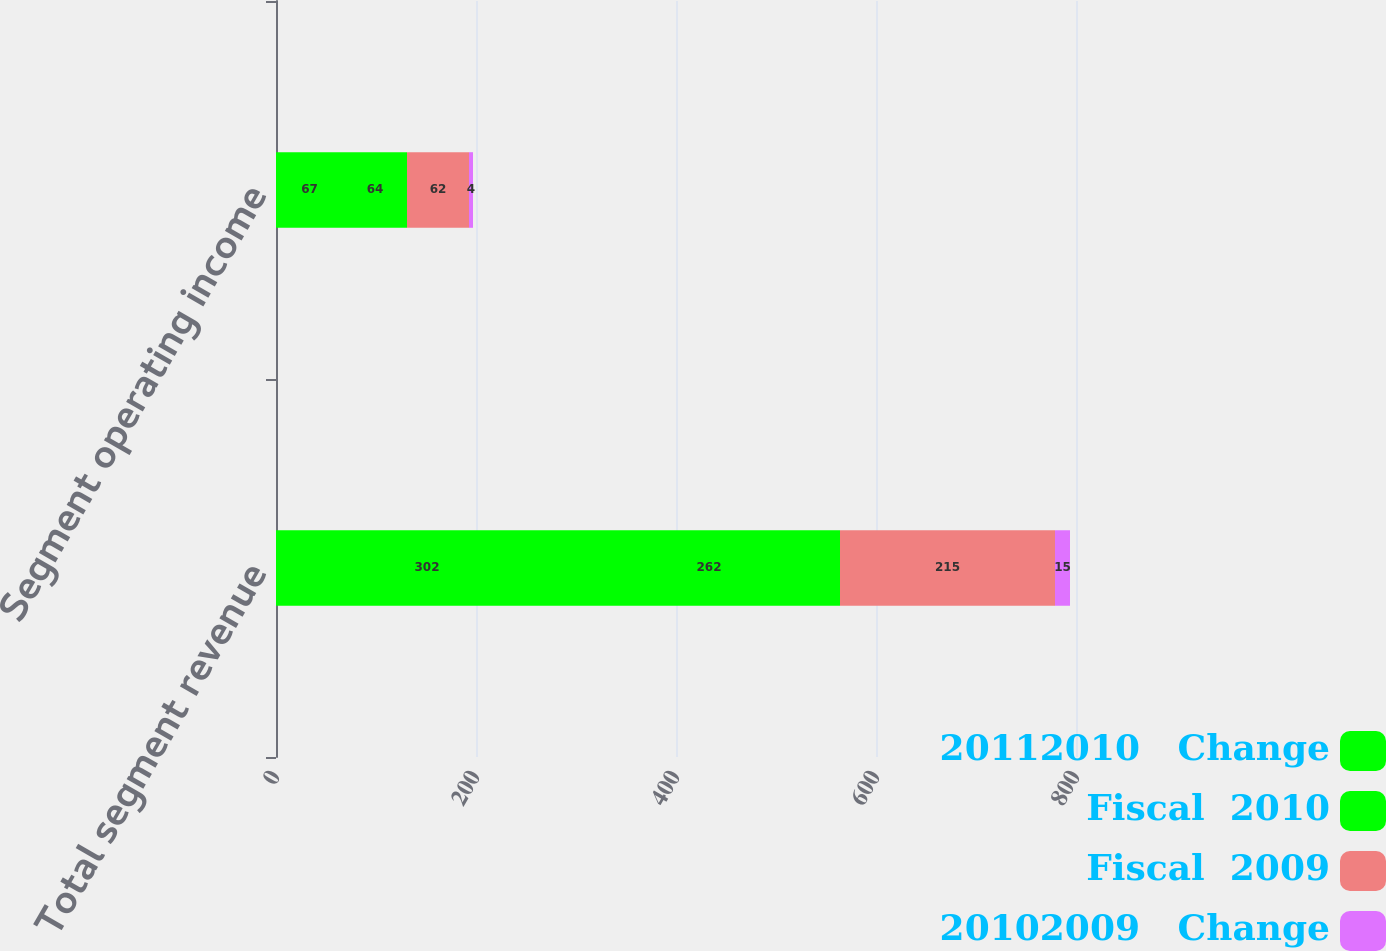<chart> <loc_0><loc_0><loc_500><loc_500><stacked_bar_chart><ecel><fcel>Total segment revenue<fcel>Segment operating income<nl><fcel>20112010   Change<fcel>302<fcel>67<nl><fcel>Fiscal  2010<fcel>262<fcel>64<nl><fcel>Fiscal  2009<fcel>215<fcel>62<nl><fcel>20102009   Change<fcel>15<fcel>4<nl></chart> 